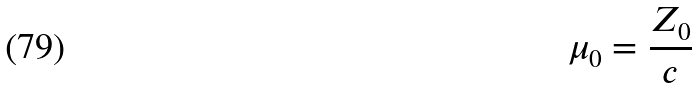Convert formula to latex. <formula><loc_0><loc_0><loc_500><loc_500>\mu _ { 0 } = { \frac { Z _ { 0 } } { c } }</formula> 